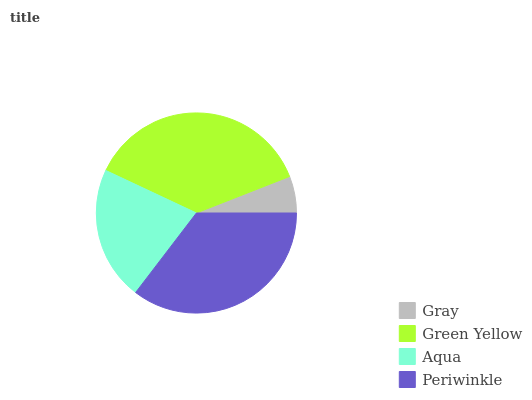Is Gray the minimum?
Answer yes or no. Yes. Is Green Yellow the maximum?
Answer yes or no. Yes. Is Aqua the minimum?
Answer yes or no. No. Is Aqua the maximum?
Answer yes or no. No. Is Green Yellow greater than Aqua?
Answer yes or no. Yes. Is Aqua less than Green Yellow?
Answer yes or no. Yes. Is Aqua greater than Green Yellow?
Answer yes or no. No. Is Green Yellow less than Aqua?
Answer yes or no. No. Is Periwinkle the high median?
Answer yes or no. Yes. Is Aqua the low median?
Answer yes or no. Yes. Is Aqua the high median?
Answer yes or no. No. Is Gray the low median?
Answer yes or no. No. 